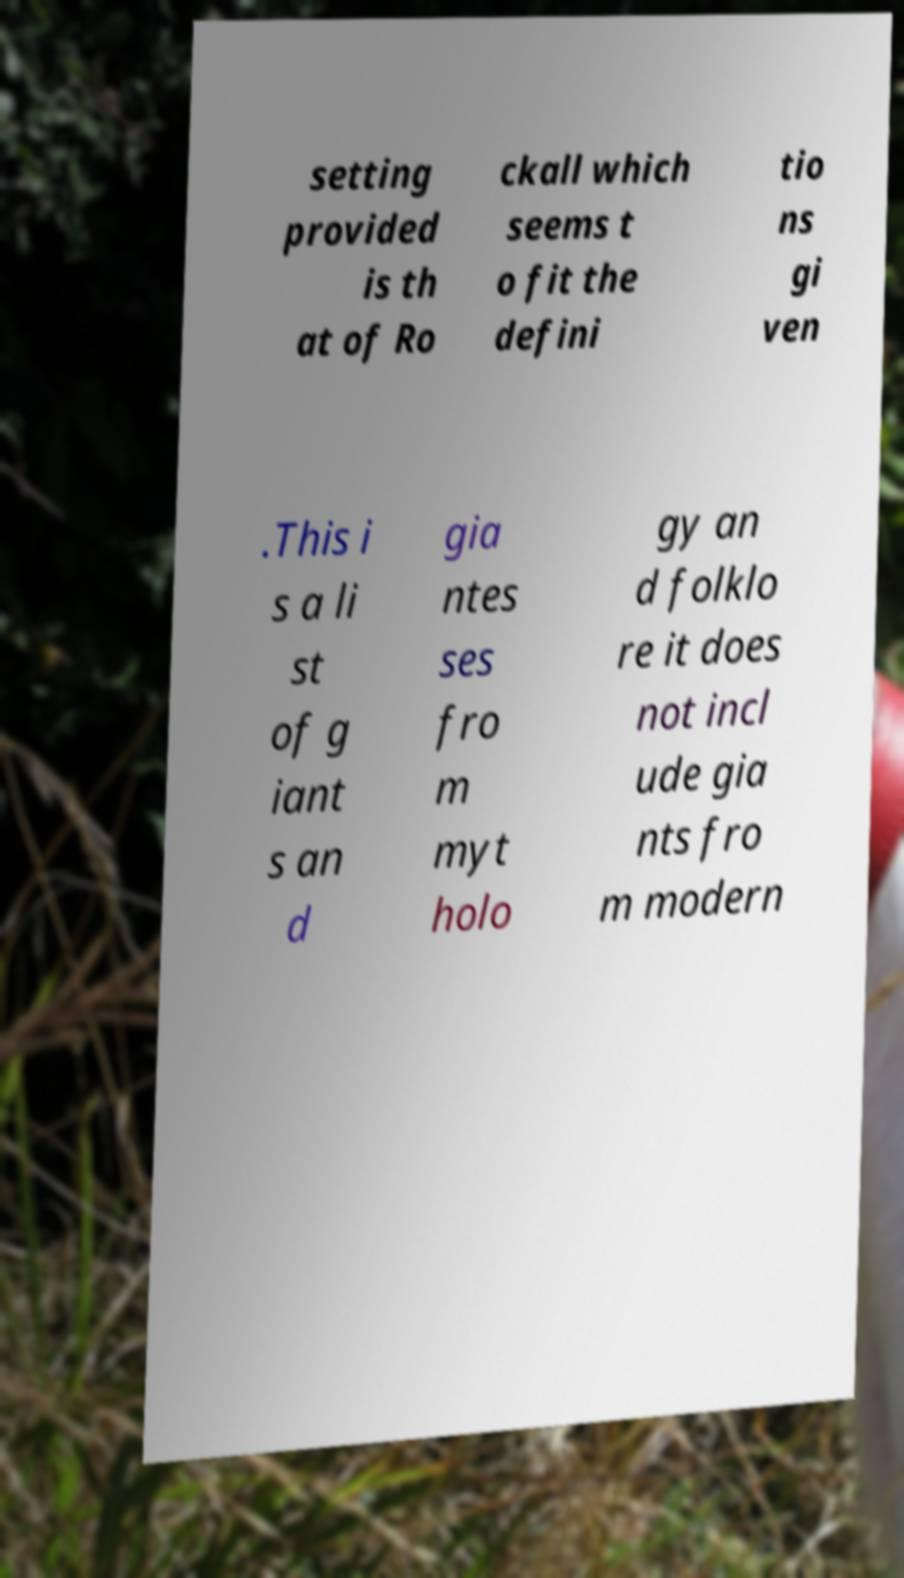I need the written content from this picture converted into text. Can you do that? setting provided is th at of Ro ckall which seems t o fit the defini tio ns gi ven .This i s a li st of g iant s an d gia ntes ses fro m myt holo gy an d folklo re it does not incl ude gia nts fro m modern 